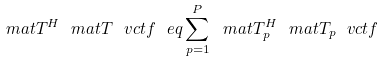Convert formula to latex. <formula><loc_0><loc_0><loc_500><loc_500>\ m a t T ^ { H } \ m a t T \ v c t f \ e q \sum _ { p = 1 } ^ { P } \ m a t T _ { p } ^ { H } \ m a t T _ { p } \ v c t f</formula> 